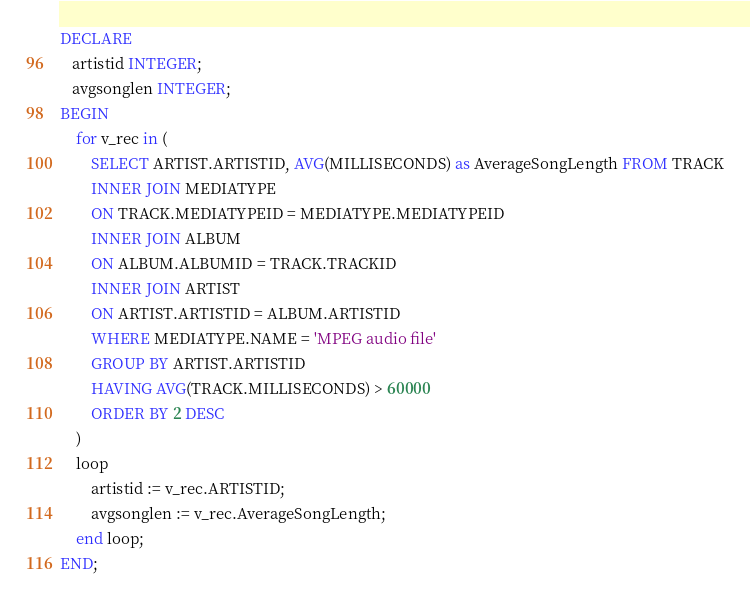Convert code to text. <code><loc_0><loc_0><loc_500><loc_500><_SQL_>DECLARE
   artistid INTEGER;
   avgsonglen INTEGER;
BEGIN
	for v_rec in (
		SELECT ARTIST.ARTISTID, AVG(MILLISECONDS) as AverageSongLength FROM TRACK
		INNER JOIN MEDIATYPE
		ON TRACK.MEDIATYPEID = MEDIATYPE.MEDIATYPEID
		INNER JOIN ALBUM
		ON ALBUM.ALBUMID = TRACK.TRACKID
		INNER JOIN ARTIST
		ON ARTIST.ARTISTID = ALBUM.ARTISTID
		WHERE MEDIATYPE.NAME = 'MPEG audio file'
		GROUP BY ARTIST.ARTISTID
		HAVING AVG(TRACK.MILLISECONDS) > 60000
		ORDER BY 2 DESC
	) 
	loop
		artistid := v_rec.ARTISTID;
		avgsonglen := v_rec.AverageSongLength;
	end loop;
END;
</code> 